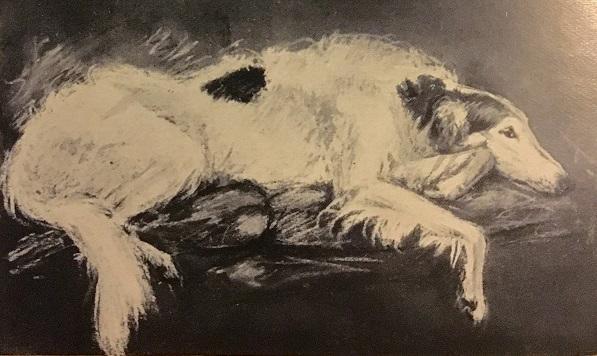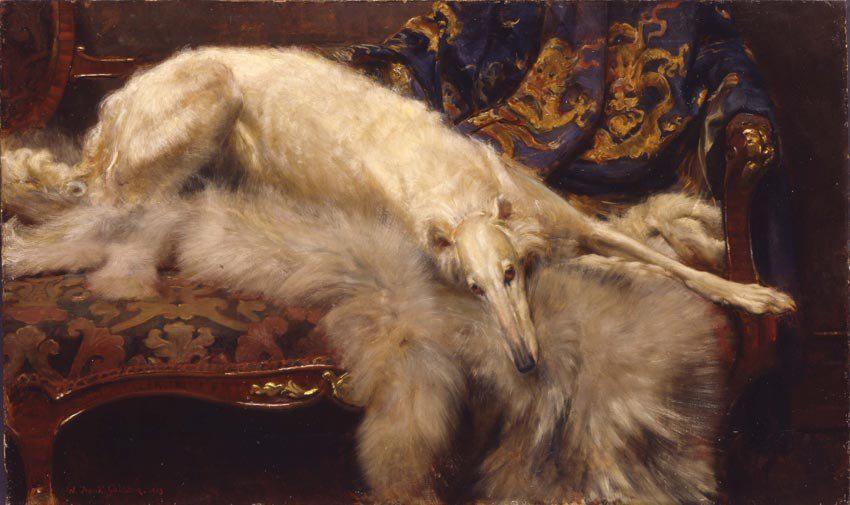The first image is the image on the left, the second image is the image on the right. Considering the images on both sides, is "The dogs in the image on the right are outside." valid? Answer yes or no. No. 